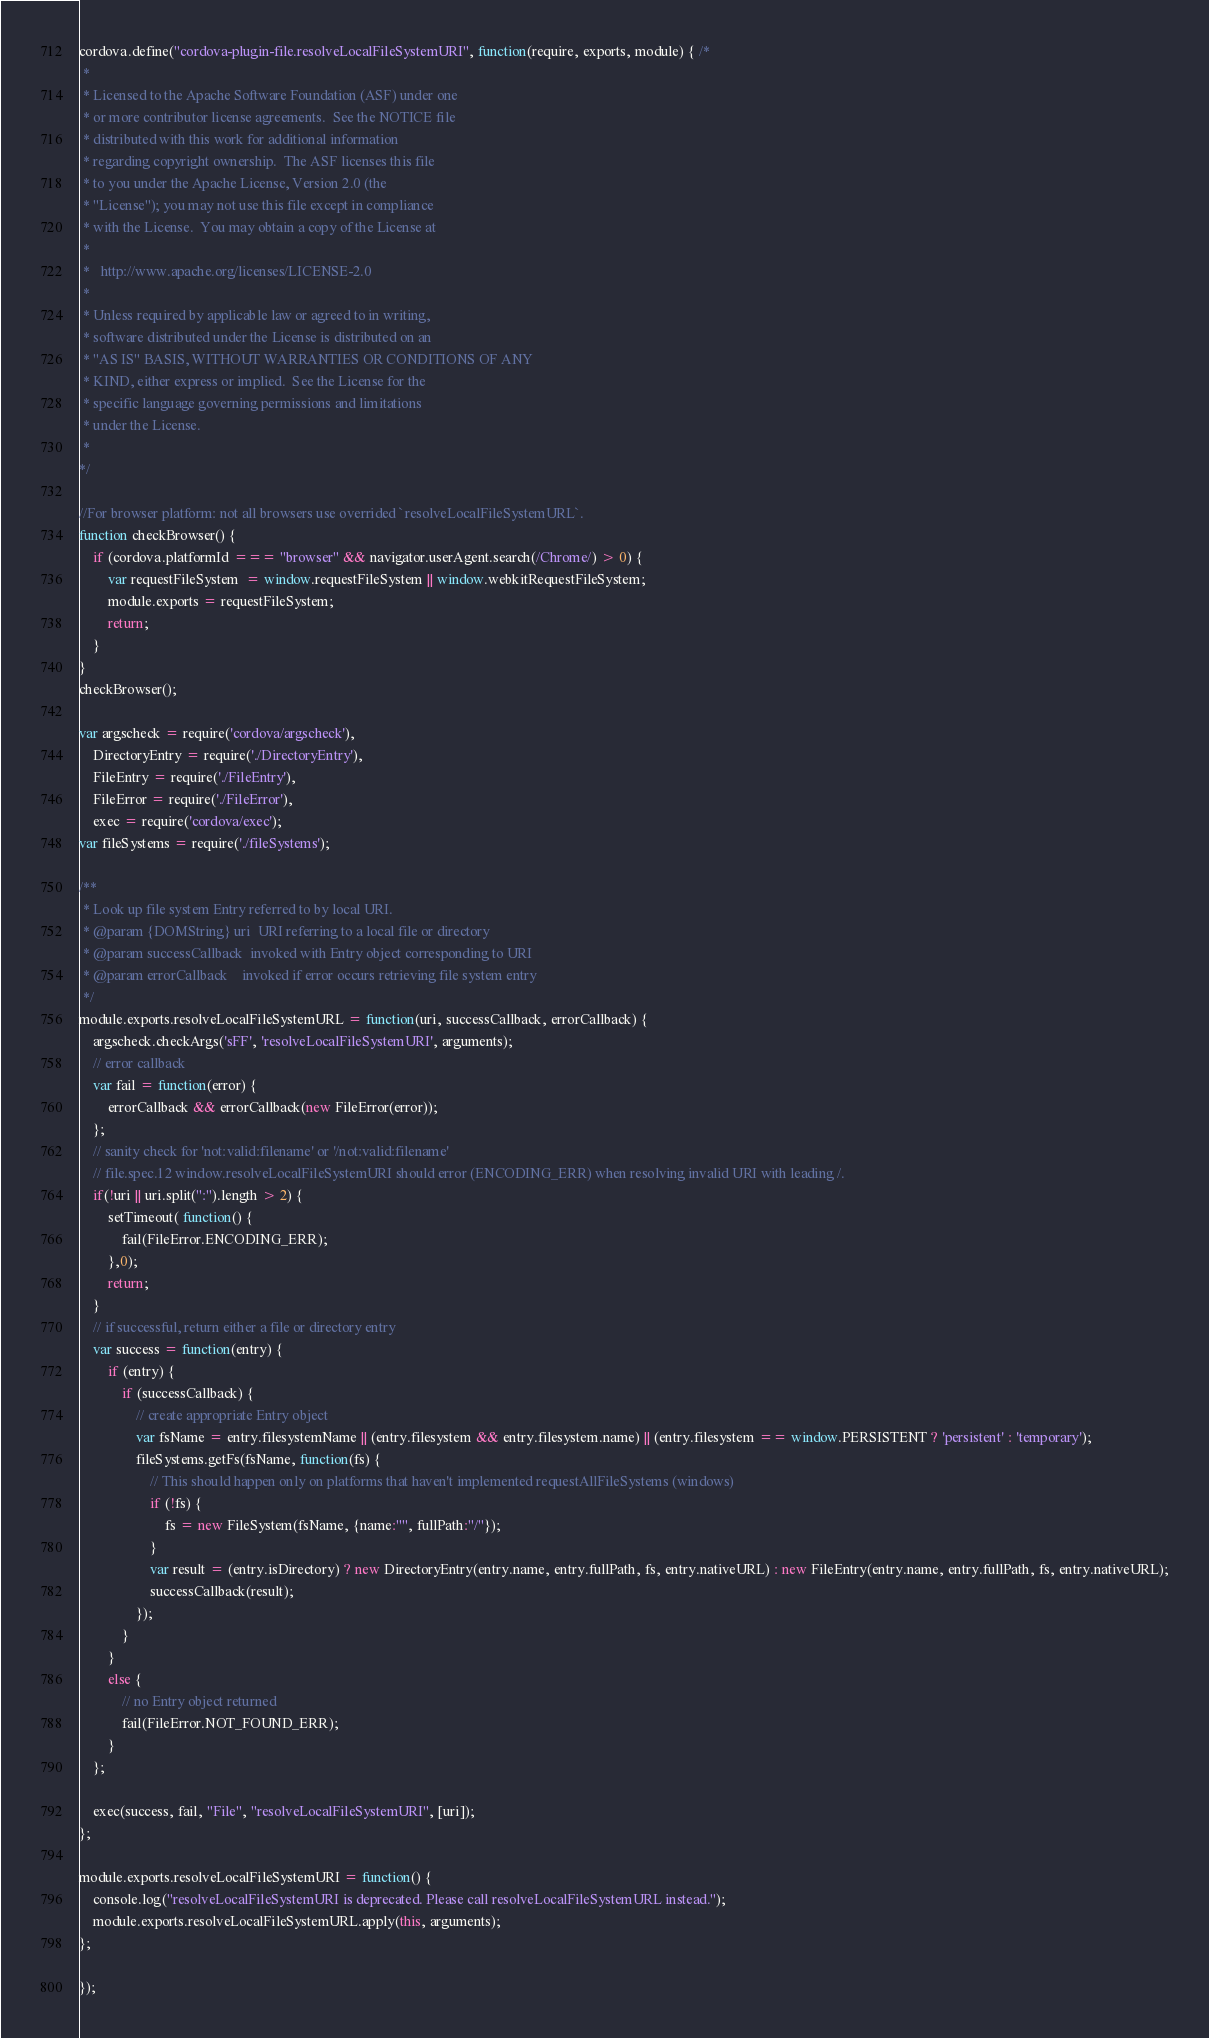Convert code to text. <code><loc_0><loc_0><loc_500><loc_500><_JavaScript_>cordova.define("cordova-plugin-file.resolveLocalFileSystemURI", function(require, exports, module) { /*
 *
 * Licensed to the Apache Software Foundation (ASF) under one
 * or more contributor license agreements.  See the NOTICE file
 * distributed with this work for additional information
 * regarding copyright ownership.  The ASF licenses this file
 * to you under the Apache License, Version 2.0 (the
 * "License"); you may not use this file except in compliance
 * with the License.  You may obtain a copy of the License at
 *
 *   http://www.apache.org/licenses/LICENSE-2.0
 *
 * Unless required by applicable law or agreed to in writing,
 * software distributed under the License is distributed on an
 * "AS IS" BASIS, WITHOUT WARRANTIES OR CONDITIONS OF ANY
 * KIND, either express or implied.  See the License for the
 * specific language governing permissions and limitations
 * under the License.
 *
*/

//For browser platform: not all browsers use overrided `resolveLocalFileSystemURL`.
function checkBrowser() {
    if (cordova.platformId === "browser" && navigator.userAgent.search(/Chrome/) > 0) {
        var requestFileSystem  = window.requestFileSystem || window.webkitRequestFileSystem;
        module.exports = requestFileSystem;
        return;
    }
}
checkBrowser();

var argscheck = require('cordova/argscheck'),
    DirectoryEntry = require('./DirectoryEntry'),
    FileEntry = require('./FileEntry'),
    FileError = require('./FileError'),
    exec = require('cordova/exec');
var fileSystems = require('./fileSystems');

/**
 * Look up file system Entry referred to by local URI.
 * @param {DOMString} uri  URI referring to a local file or directory
 * @param successCallback  invoked with Entry object corresponding to URI
 * @param errorCallback    invoked if error occurs retrieving file system entry
 */
module.exports.resolveLocalFileSystemURL = function(uri, successCallback, errorCallback) {
    argscheck.checkArgs('sFF', 'resolveLocalFileSystemURI', arguments);
    // error callback
    var fail = function(error) {
        errorCallback && errorCallback(new FileError(error));
    };
    // sanity check for 'not:valid:filename' or '/not:valid:filename'
    // file.spec.12 window.resolveLocalFileSystemURI should error (ENCODING_ERR) when resolving invalid URI with leading /.
    if(!uri || uri.split(":").length > 2) {
        setTimeout( function() {
            fail(FileError.ENCODING_ERR);
        },0);
        return;
    }
    // if successful, return either a file or directory entry
    var success = function(entry) {
        if (entry) {
            if (successCallback) {
                // create appropriate Entry object
                var fsName = entry.filesystemName || (entry.filesystem && entry.filesystem.name) || (entry.filesystem == window.PERSISTENT ? 'persistent' : 'temporary');
                fileSystems.getFs(fsName, function(fs) {
                    // This should happen only on platforms that haven't implemented requestAllFileSystems (windows)
                    if (!fs) {
                        fs = new FileSystem(fsName, {name:"", fullPath:"/"});
                    }
                    var result = (entry.isDirectory) ? new DirectoryEntry(entry.name, entry.fullPath, fs, entry.nativeURL) : new FileEntry(entry.name, entry.fullPath, fs, entry.nativeURL);
                    successCallback(result);
                });
            }
        }
        else {
            // no Entry object returned
            fail(FileError.NOT_FOUND_ERR);
        }
    };

    exec(success, fail, "File", "resolveLocalFileSystemURI", [uri]);
};

module.exports.resolveLocalFileSystemURI = function() {
    console.log("resolveLocalFileSystemURI is deprecated. Please call resolveLocalFileSystemURL instead.");
    module.exports.resolveLocalFileSystemURL.apply(this, arguments);
};

});
</code> 